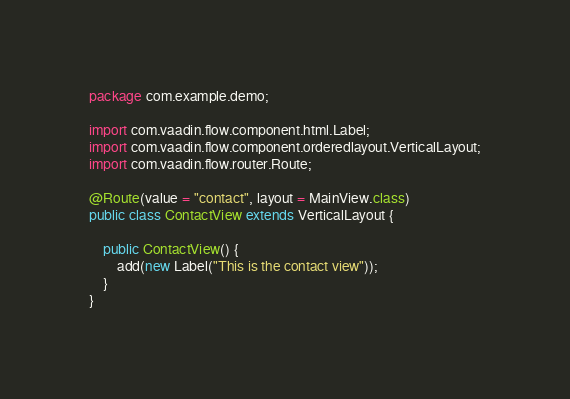Convert code to text. <code><loc_0><loc_0><loc_500><loc_500><_Java_>package com.example.demo;

import com.vaadin.flow.component.html.Label;
import com.vaadin.flow.component.orderedlayout.VerticalLayout;
import com.vaadin.flow.router.Route;

@Route(value = "contact", layout = MainView.class)
public class ContactView extends VerticalLayout {

    public ContactView() {
        add(new Label("This is the contact view"));
    }
}
</code> 